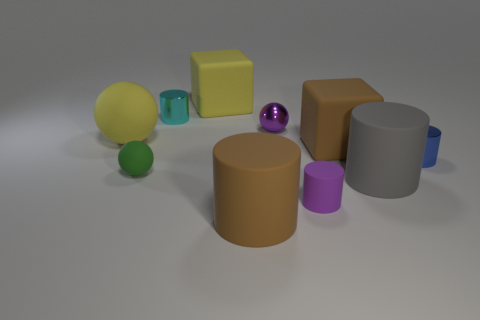How does the arrangement of shapes in the image relate to one another? The arrangement of shapes in the image appears carefully balanced with a variety of geometric forms. Each object has been placed with consideration to proportion and spacing, creating an aesthetic composition that captures attention and evokes a sense of organized diversity. 